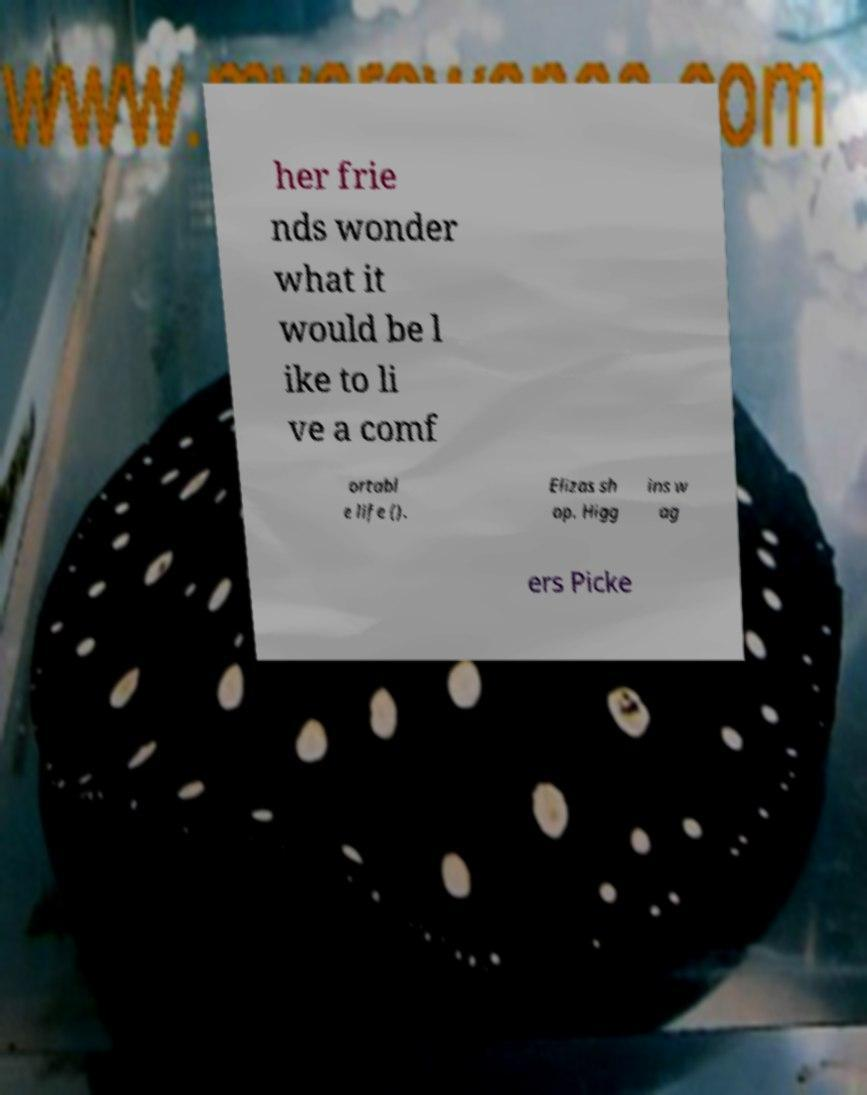There's text embedded in this image that I need extracted. Can you transcribe it verbatim? her frie nds wonder what it would be l ike to li ve a comf ortabl e life (). Elizas sh op. Higg ins w ag ers Picke 